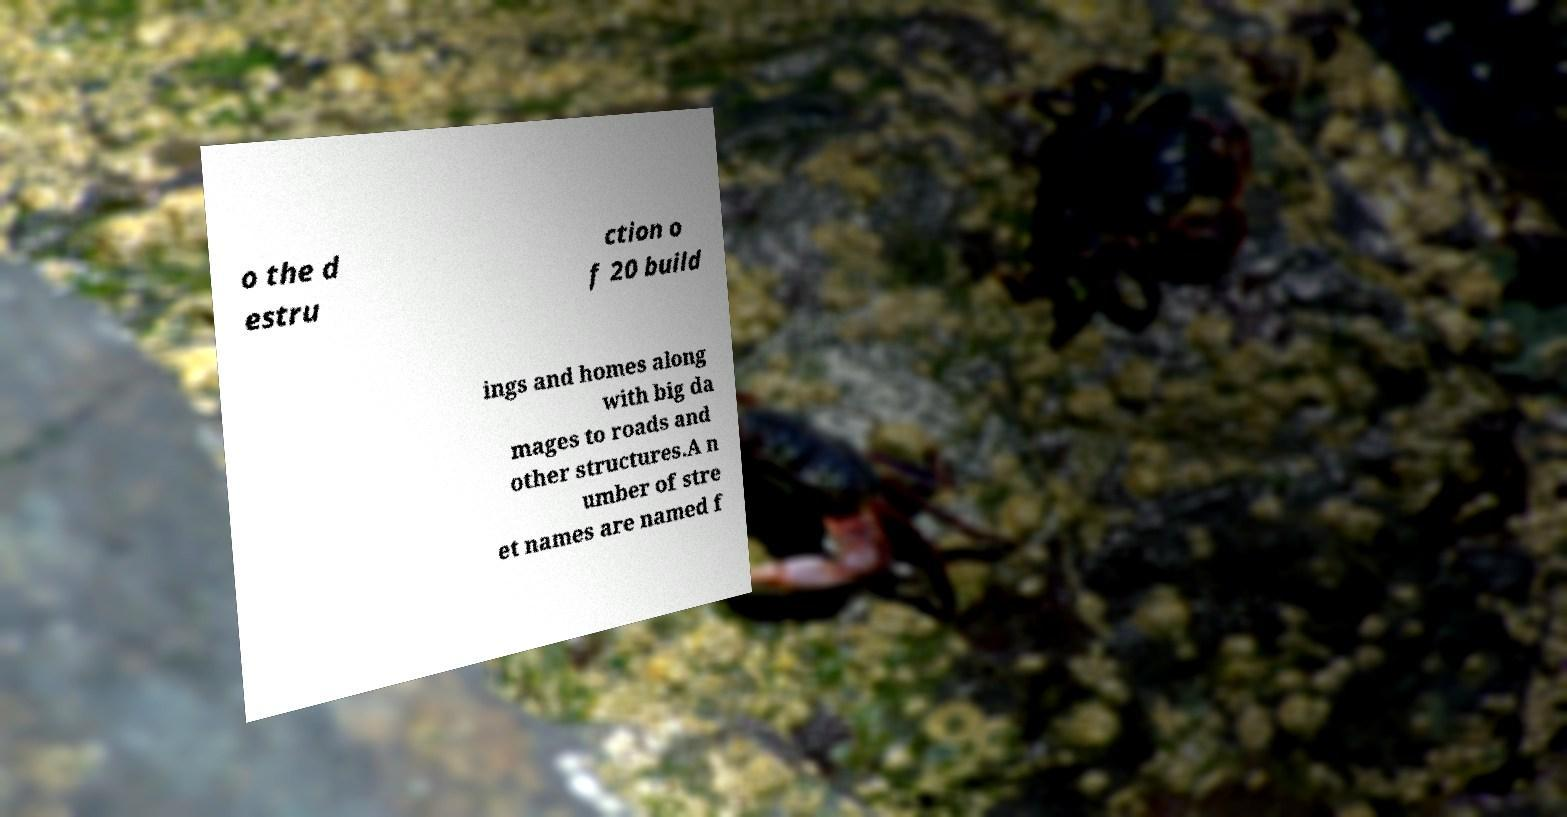Could you extract and type out the text from this image? o the d estru ction o f 20 build ings and homes along with big da mages to roads and other structures.A n umber of stre et names are named f 